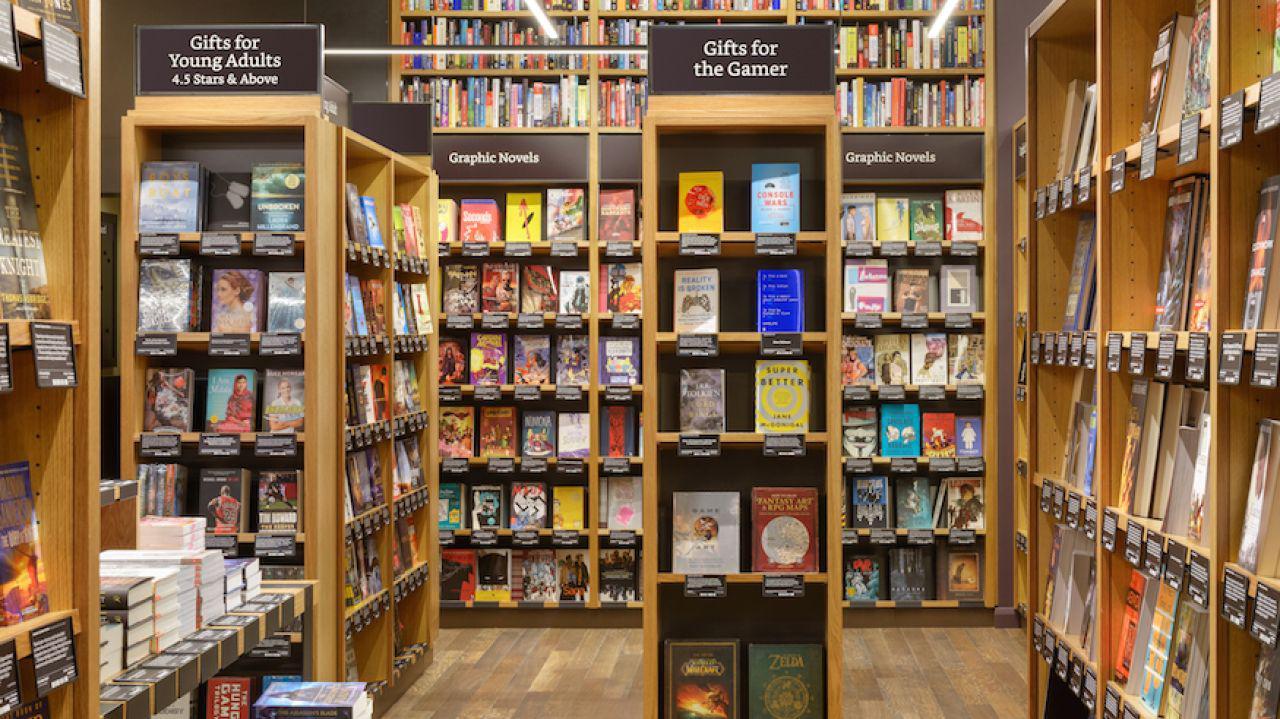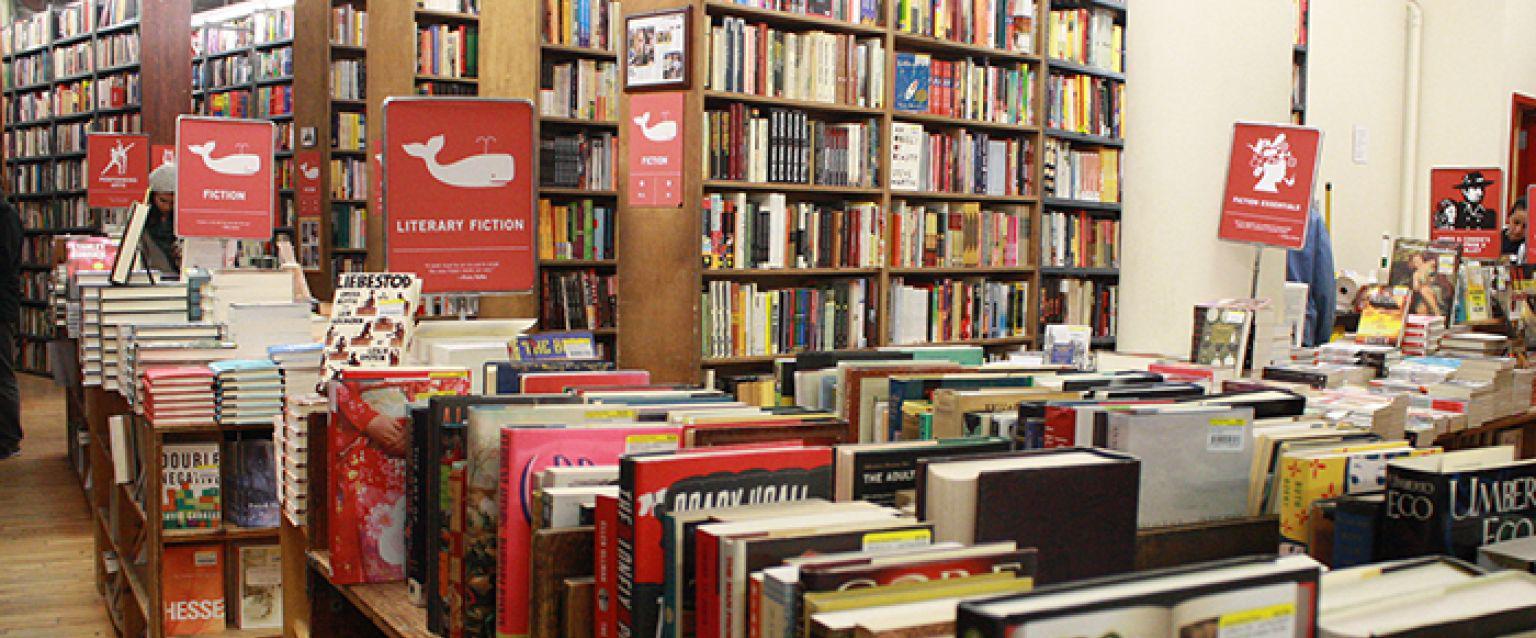The first image is the image on the left, the second image is the image on the right. For the images shown, is this caption "One or more customers are shown in a bookstore." true? Answer yes or no. No. 